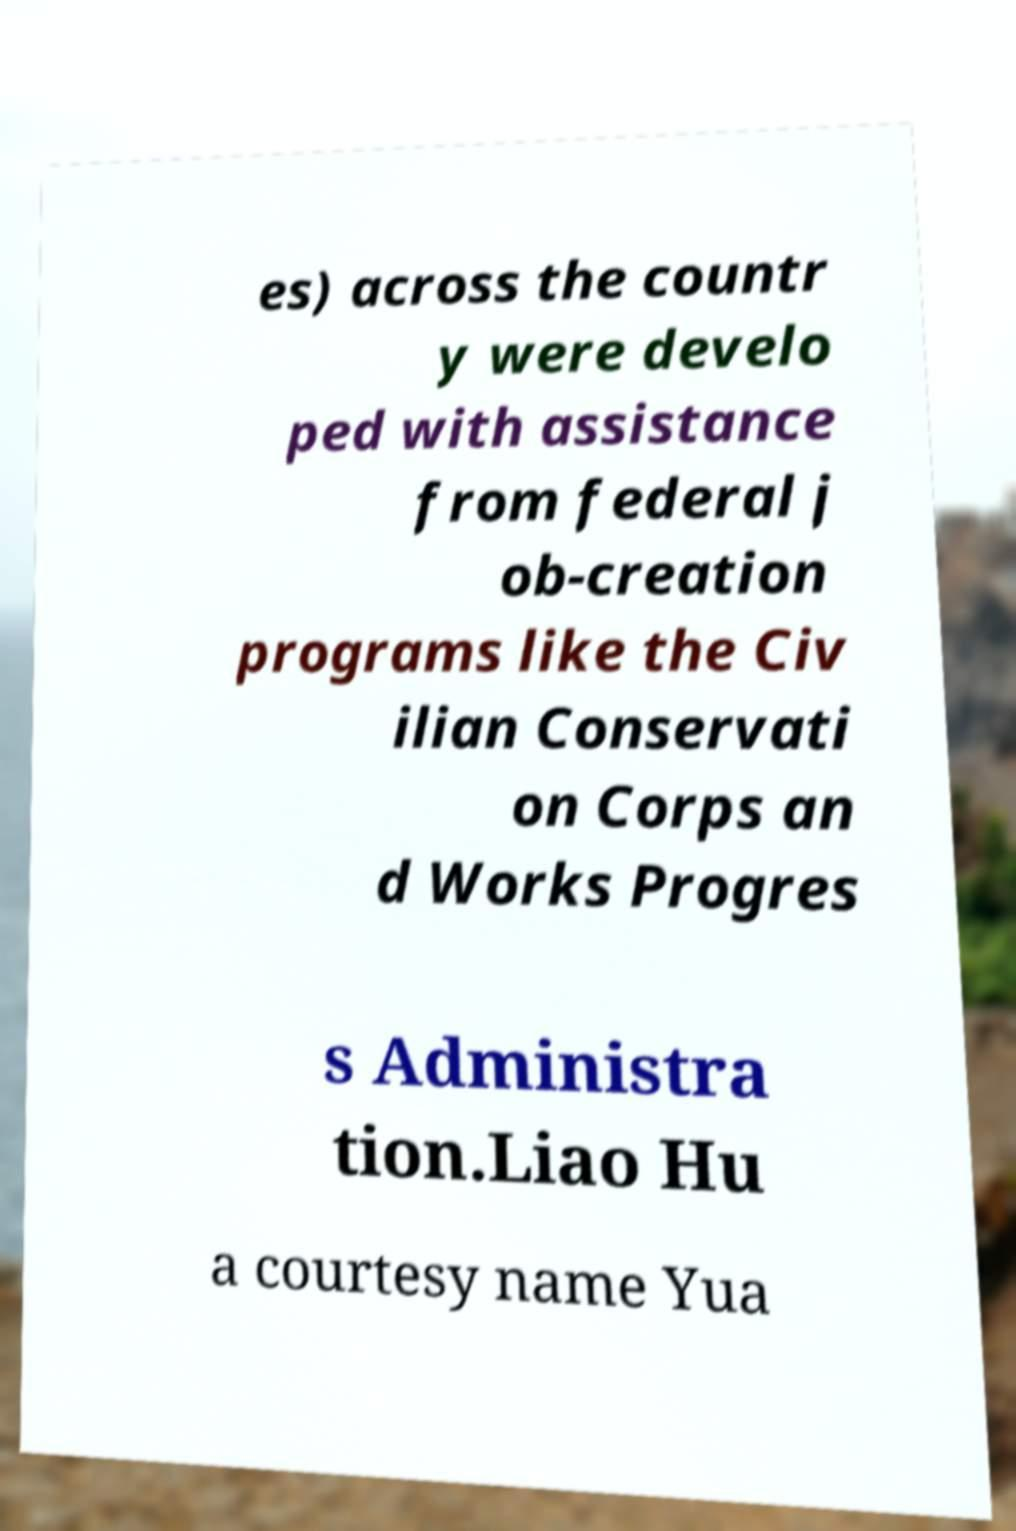Could you assist in decoding the text presented in this image and type it out clearly? es) across the countr y were develo ped with assistance from federal j ob-creation programs like the Civ ilian Conservati on Corps an d Works Progres s Administra tion.Liao Hu a courtesy name Yua 